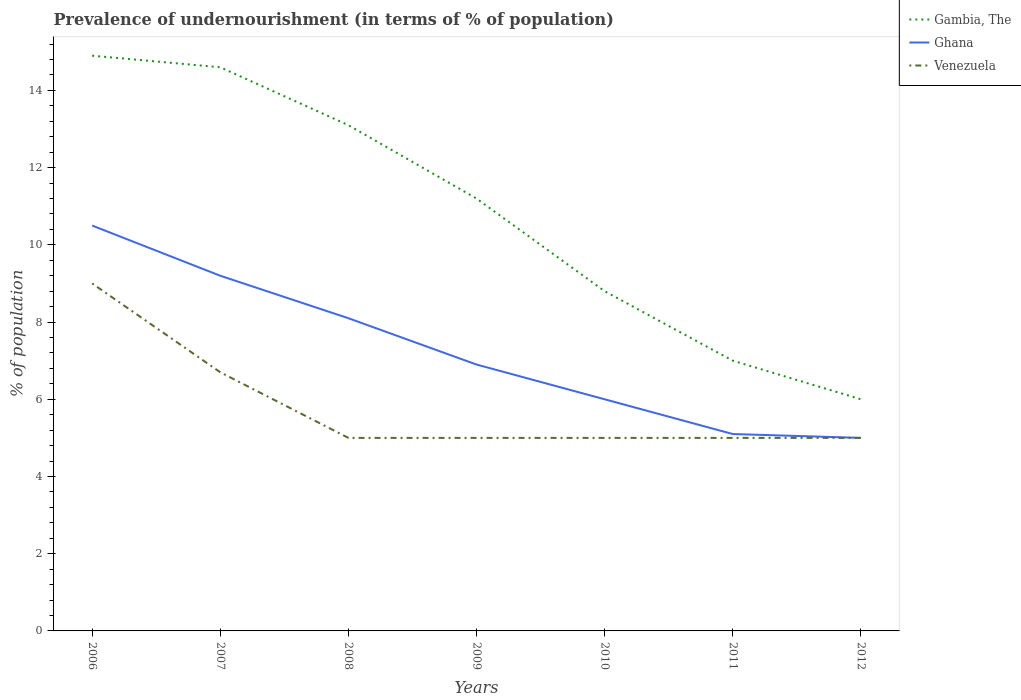How many different coloured lines are there?
Ensure brevity in your answer.  3. Does the line corresponding to Gambia, The intersect with the line corresponding to Venezuela?
Provide a short and direct response. No. In which year was the percentage of undernourished population in Venezuela maximum?
Provide a succinct answer. 2008. What is the total percentage of undernourished population in Ghana in the graph?
Your answer should be very brief. 0.9. What is the difference between the highest and the lowest percentage of undernourished population in Venezuela?
Your answer should be very brief. 2. How many lines are there?
Your response must be concise. 3. How many years are there in the graph?
Provide a succinct answer. 7. What is the difference between two consecutive major ticks on the Y-axis?
Give a very brief answer. 2. Does the graph contain any zero values?
Provide a succinct answer. No. Does the graph contain grids?
Your answer should be compact. No. Where does the legend appear in the graph?
Your answer should be compact. Top right. How many legend labels are there?
Offer a very short reply. 3. What is the title of the graph?
Ensure brevity in your answer.  Prevalence of undernourishment (in terms of % of population). Does "New Caledonia" appear as one of the legend labels in the graph?
Your response must be concise. No. What is the label or title of the X-axis?
Provide a succinct answer. Years. What is the label or title of the Y-axis?
Provide a short and direct response. % of population. What is the % of population of Ghana in 2007?
Provide a succinct answer. 9.2. What is the % of population in Venezuela in 2007?
Your response must be concise. 6.7. What is the % of population of Gambia, The in 2008?
Provide a short and direct response. 13.1. What is the % of population of Gambia, The in 2010?
Your response must be concise. 8.8. What is the % of population of Ghana in 2010?
Provide a succinct answer. 6. What is the % of population of Gambia, The in 2011?
Your answer should be compact. 7. What is the % of population in Gambia, The in 2012?
Offer a terse response. 6. What is the % of population of Ghana in 2012?
Offer a terse response. 5. What is the % of population in Venezuela in 2012?
Make the answer very short. 5. Across all years, what is the maximum % of population in Ghana?
Your response must be concise. 10.5. Across all years, what is the maximum % of population in Venezuela?
Keep it short and to the point. 9. Across all years, what is the minimum % of population in Gambia, The?
Your answer should be very brief. 6. Across all years, what is the minimum % of population in Venezuela?
Provide a short and direct response. 5. What is the total % of population of Gambia, The in the graph?
Your answer should be compact. 75.6. What is the total % of population in Ghana in the graph?
Ensure brevity in your answer.  50.8. What is the total % of population in Venezuela in the graph?
Your response must be concise. 40.7. What is the difference between the % of population of Gambia, The in 2006 and that in 2008?
Keep it short and to the point. 1.8. What is the difference between the % of population in Venezuela in 2006 and that in 2008?
Provide a short and direct response. 4. What is the difference between the % of population in Gambia, The in 2006 and that in 2009?
Make the answer very short. 3.7. What is the difference between the % of population in Venezuela in 2006 and that in 2009?
Your answer should be very brief. 4. What is the difference between the % of population of Gambia, The in 2006 and that in 2010?
Offer a very short reply. 6.1. What is the difference between the % of population of Ghana in 2006 and that in 2010?
Give a very brief answer. 4.5. What is the difference between the % of population in Gambia, The in 2006 and that in 2011?
Your response must be concise. 7.9. What is the difference between the % of population of Venezuela in 2006 and that in 2011?
Your response must be concise. 4. What is the difference between the % of population in Gambia, The in 2007 and that in 2008?
Offer a very short reply. 1.5. What is the difference between the % of population of Gambia, The in 2007 and that in 2009?
Provide a succinct answer. 3.4. What is the difference between the % of population of Venezuela in 2007 and that in 2009?
Your answer should be very brief. 1.7. What is the difference between the % of population in Gambia, The in 2007 and that in 2010?
Your answer should be compact. 5.8. What is the difference between the % of population in Ghana in 2007 and that in 2010?
Your response must be concise. 3.2. What is the difference between the % of population of Ghana in 2007 and that in 2011?
Provide a short and direct response. 4.1. What is the difference between the % of population in Venezuela in 2007 and that in 2012?
Provide a short and direct response. 1.7. What is the difference between the % of population of Gambia, The in 2008 and that in 2009?
Provide a short and direct response. 1.9. What is the difference between the % of population in Ghana in 2008 and that in 2009?
Ensure brevity in your answer.  1.2. What is the difference between the % of population in Gambia, The in 2008 and that in 2010?
Make the answer very short. 4.3. What is the difference between the % of population in Venezuela in 2008 and that in 2010?
Your answer should be very brief. 0. What is the difference between the % of population in Gambia, The in 2008 and that in 2011?
Your response must be concise. 6.1. What is the difference between the % of population of Ghana in 2008 and that in 2011?
Provide a succinct answer. 3. What is the difference between the % of population of Gambia, The in 2008 and that in 2012?
Provide a short and direct response. 7.1. What is the difference between the % of population in Gambia, The in 2009 and that in 2011?
Your response must be concise. 4.2. What is the difference between the % of population of Ghana in 2009 and that in 2011?
Make the answer very short. 1.8. What is the difference between the % of population of Venezuela in 2009 and that in 2012?
Keep it short and to the point. 0. What is the difference between the % of population in Gambia, The in 2010 and that in 2011?
Provide a succinct answer. 1.8. What is the difference between the % of population in Ghana in 2010 and that in 2011?
Provide a short and direct response. 0.9. What is the difference between the % of population of Venezuela in 2010 and that in 2011?
Ensure brevity in your answer.  0. What is the difference between the % of population of Venezuela in 2010 and that in 2012?
Provide a short and direct response. 0. What is the difference between the % of population in Gambia, The in 2011 and that in 2012?
Offer a terse response. 1. What is the difference between the % of population of Gambia, The in 2006 and the % of population of Ghana in 2007?
Your response must be concise. 5.7. What is the difference between the % of population of Gambia, The in 2006 and the % of population of Venezuela in 2007?
Provide a succinct answer. 8.2. What is the difference between the % of population of Gambia, The in 2006 and the % of population of Venezuela in 2008?
Give a very brief answer. 9.9. What is the difference between the % of population of Ghana in 2006 and the % of population of Venezuela in 2008?
Offer a terse response. 5.5. What is the difference between the % of population in Gambia, The in 2006 and the % of population in Ghana in 2010?
Keep it short and to the point. 8.9. What is the difference between the % of population of Gambia, The in 2006 and the % of population of Ghana in 2011?
Provide a short and direct response. 9.8. What is the difference between the % of population in Gambia, The in 2006 and the % of population in Venezuela in 2011?
Your response must be concise. 9.9. What is the difference between the % of population of Gambia, The in 2006 and the % of population of Ghana in 2012?
Your answer should be very brief. 9.9. What is the difference between the % of population in Ghana in 2006 and the % of population in Venezuela in 2012?
Offer a very short reply. 5.5. What is the difference between the % of population in Gambia, The in 2007 and the % of population in Ghana in 2008?
Offer a very short reply. 6.5. What is the difference between the % of population in Gambia, The in 2007 and the % of population in Venezuela in 2008?
Your response must be concise. 9.6. What is the difference between the % of population of Ghana in 2007 and the % of population of Venezuela in 2008?
Your answer should be compact. 4.2. What is the difference between the % of population of Gambia, The in 2007 and the % of population of Ghana in 2009?
Ensure brevity in your answer.  7.7. What is the difference between the % of population in Gambia, The in 2007 and the % of population in Ghana in 2010?
Give a very brief answer. 8.6. What is the difference between the % of population in Gambia, The in 2007 and the % of population in Venezuela in 2010?
Your answer should be very brief. 9.6. What is the difference between the % of population in Ghana in 2007 and the % of population in Venezuela in 2010?
Make the answer very short. 4.2. What is the difference between the % of population in Gambia, The in 2007 and the % of population in Venezuela in 2011?
Provide a succinct answer. 9.6. What is the difference between the % of population of Ghana in 2007 and the % of population of Venezuela in 2011?
Make the answer very short. 4.2. What is the difference between the % of population in Gambia, The in 2007 and the % of population in Ghana in 2012?
Provide a succinct answer. 9.6. What is the difference between the % of population of Ghana in 2007 and the % of population of Venezuela in 2012?
Keep it short and to the point. 4.2. What is the difference between the % of population in Gambia, The in 2008 and the % of population in Venezuela in 2009?
Offer a very short reply. 8.1. What is the difference between the % of population in Gambia, The in 2008 and the % of population in Ghana in 2010?
Your response must be concise. 7.1. What is the difference between the % of population of Gambia, The in 2008 and the % of population of Venezuela in 2010?
Offer a very short reply. 8.1. What is the difference between the % of population of Ghana in 2008 and the % of population of Venezuela in 2010?
Offer a terse response. 3.1. What is the difference between the % of population of Gambia, The in 2008 and the % of population of Ghana in 2011?
Offer a terse response. 8. What is the difference between the % of population in Gambia, The in 2008 and the % of population in Ghana in 2012?
Your answer should be very brief. 8.1. What is the difference between the % of population in Ghana in 2009 and the % of population in Venezuela in 2010?
Provide a succinct answer. 1.9. What is the difference between the % of population in Ghana in 2009 and the % of population in Venezuela in 2011?
Provide a succinct answer. 1.9. What is the difference between the % of population of Gambia, The in 2009 and the % of population of Ghana in 2012?
Provide a succinct answer. 6.2. What is the difference between the % of population of Gambia, The in 2009 and the % of population of Venezuela in 2012?
Ensure brevity in your answer.  6.2. What is the difference between the % of population in Gambia, The in 2010 and the % of population in Ghana in 2011?
Your response must be concise. 3.7. What is the difference between the % of population in Gambia, The in 2010 and the % of population in Venezuela in 2011?
Ensure brevity in your answer.  3.8. What is the difference between the % of population of Ghana in 2010 and the % of population of Venezuela in 2011?
Your answer should be very brief. 1. What is the difference between the % of population in Gambia, The in 2010 and the % of population in Ghana in 2012?
Make the answer very short. 3.8. What is the difference between the % of population in Gambia, The in 2010 and the % of population in Venezuela in 2012?
Give a very brief answer. 3.8. What is the difference between the % of population in Gambia, The in 2011 and the % of population in Ghana in 2012?
Your response must be concise. 2. What is the difference between the % of population of Gambia, The in 2011 and the % of population of Venezuela in 2012?
Offer a terse response. 2. What is the difference between the % of population of Ghana in 2011 and the % of population of Venezuela in 2012?
Keep it short and to the point. 0.1. What is the average % of population of Gambia, The per year?
Give a very brief answer. 10.8. What is the average % of population in Ghana per year?
Offer a very short reply. 7.26. What is the average % of population in Venezuela per year?
Offer a very short reply. 5.81. In the year 2006, what is the difference between the % of population in Gambia, The and % of population in Ghana?
Make the answer very short. 4.4. In the year 2006, what is the difference between the % of population of Gambia, The and % of population of Venezuela?
Offer a very short reply. 5.9. In the year 2007, what is the difference between the % of population of Ghana and % of population of Venezuela?
Provide a succinct answer. 2.5. In the year 2008, what is the difference between the % of population in Gambia, The and % of population in Ghana?
Your answer should be very brief. 5. In the year 2008, what is the difference between the % of population of Ghana and % of population of Venezuela?
Offer a terse response. 3.1. In the year 2010, what is the difference between the % of population in Gambia, The and % of population in Ghana?
Keep it short and to the point. 2.8. In the year 2011, what is the difference between the % of population of Gambia, The and % of population of Venezuela?
Your response must be concise. 2. What is the ratio of the % of population of Gambia, The in 2006 to that in 2007?
Make the answer very short. 1.02. What is the ratio of the % of population in Ghana in 2006 to that in 2007?
Your answer should be compact. 1.14. What is the ratio of the % of population of Venezuela in 2006 to that in 2007?
Give a very brief answer. 1.34. What is the ratio of the % of population in Gambia, The in 2006 to that in 2008?
Make the answer very short. 1.14. What is the ratio of the % of population of Ghana in 2006 to that in 2008?
Provide a succinct answer. 1.3. What is the ratio of the % of population of Venezuela in 2006 to that in 2008?
Your answer should be compact. 1.8. What is the ratio of the % of population of Gambia, The in 2006 to that in 2009?
Provide a succinct answer. 1.33. What is the ratio of the % of population of Ghana in 2006 to that in 2009?
Offer a terse response. 1.52. What is the ratio of the % of population in Gambia, The in 2006 to that in 2010?
Offer a very short reply. 1.69. What is the ratio of the % of population of Gambia, The in 2006 to that in 2011?
Ensure brevity in your answer.  2.13. What is the ratio of the % of population of Ghana in 2006 to that in 2011?
Make the answer very short. 2.06. What is the ratio of the % of population of Gambia, The in 2006 to that in 2012?
Offer a very short reply. 2.48. What is the ratio of the % of population in Gambia, The in 2007 to that in 2008?
Keep it short and to the point. 1.11. What is the ratio of the % of population in Ghana in 2007 to that in 2008?
Give a very brief answer. 1.14. What is the ratio of the % of population of Venezuela in 2007 to that in 2008?
Offer a terse response. 1.34. What is the ratio of the % of population in Gambia, The in 2007 to that in 2009?
Your answer should be compact. 1.3. What is the ratio of the % of population in Ghana in 2007 to that in 2009?
Make the answer very short. 1.33. What is the ratio of the % of population in Venezuela in 2007 to that in 2009?
Offer a terse response. 1.34. What is the ratio of the % of population in Gambia, The in 2007 to that in 2010?
Your answer should be very brief. 1.66. What is the ratio of the % of population of Ghana in 2007 to that in 2010?
Your answer should be compact. 1.53. What is the ratio of the % of population of Venezuela in 2007 to that in 2010?
Keep it short and to the point. 1.34. What is the ratio of the % of population of Gambia, The in 2007 to that in 2011?
Provide a short and direct response. 2.09. What is the ratio of the % of population in Ghana in 2007 to that in 2011?
Offer a very short reply. 1.8. What is the ratio of the % of population in Venezuela in 2007 to that in 2011?
Ensure brevity in your answer.  1.34. What is the ratio of the % of population in Gambia, The in 2007 to that in 2012?
Ensure brevity in your answer.  2.43. What is the ratio of the % of population in Ghana in 2007 to that in 2012?
Offer a terse response. 1.84. What is the ratio of the % of population of Venezuela in 2007 to that in 2012?
Offer a terse response. 1.34. What is the ratio of the % of population of Gambia, The in 2008 to that in 2009?
Provide a succinct answer. 1.17. What is the ratio of the % of population of Ghana in 2008 to that in 2009?
Ensure brevity in your answer.  1.17. What is the ratio of the % of population of Venezuela in 2008 to that in 2009?
Give a very brief answer. 1. What is the ratio of the % of population of Gambia, The in 2008 to that in 2010?
Give a very brief answer. 1.49. What is the ratio of the % of population in Ghana in 2008 to that in 2010?
Ensure brevity in your answer.  1.35. What is the ratio of the % of population in Venezuela in 2008 to that in 2010?
Provide a succinct answer. 1. What is the ratio of the % of population of Gambia, The in 2008 to that in 2011?
Your answer should be compact. 1.87. What is the ratio of the % of population of Ghana in 2008 to that in 2011?
Offer a very short reply. 1.59. What is the ratio of the % of population in Venezuela in 2008 to that in 2011?
Your response must be concise. 1. What is the ratio of the % of population in Gambia, The in 2008 to that in 2012?
Offer a very short reply. 2.18. What is the ratio of the % of population of Ghana in 2008 to that in 2012?
Keep it short and to the point. 1.62. What is the ratio of the % of population in Gambia, The in 2009 to that in 2010?
Your answer should be compact. 1.27. What is the ratio of the % of population in Ghana in 2009 to that in 2010?
Your response must be concise. 1.15. What is the ratio of the % of population of Ghana in 2009 to that in 2011?
Ensure brevity in your answer.  1.35. What is the ratio of the % of population of Gambia, The in 2009 to that in 2012?
Your answer should be very brief. 1.87. What is the ratio of the % of population in Ghana in 2009 to that in 2012?
Provide a succinct answer. 1.38. What is the ratio of the % of population in Gambia, The in 2010 to that in 2011?
Ensure brevity in your answer.  1.26. What is the ratio of the % of population of Ghana in 2010 to that in 2011?
Your answer should be compact. 1.18. What is the ratio of the % of population of Venezuela in 2010 to that in 2011?
Offer a terse response. 1. What is the ratio of the % of population of Gambia, The in 2010 to that in 2012?
Offer a terse response. 1.47. What is the ratio of the % of population in Ghana in 2010 to that in 2012?
Offer a terse response. 1.2. What is the ratio of the % of population of Venezuela in 2010 to that in 2012?
Ensure brevity in your answer.  1. What is the ratio of the % of population of Ghana in 2011 to that in 2012?
Provide a succinct answer. 1.02. What is the ratio of the % of population of Venezuela in 2011 to that in 2012?
Give a very brief answer. 1. What is the difference between the highest and the second highest % of population of Gambia, The?
Offer a terse response. 0.3. What is the difference between the highest and the second highest % of population in Venezuela?
Keep it short and to the point. 2.3. What is the difference between the highest and the lowest % of population in Ghana?
Offer a terse response. 5.5. 